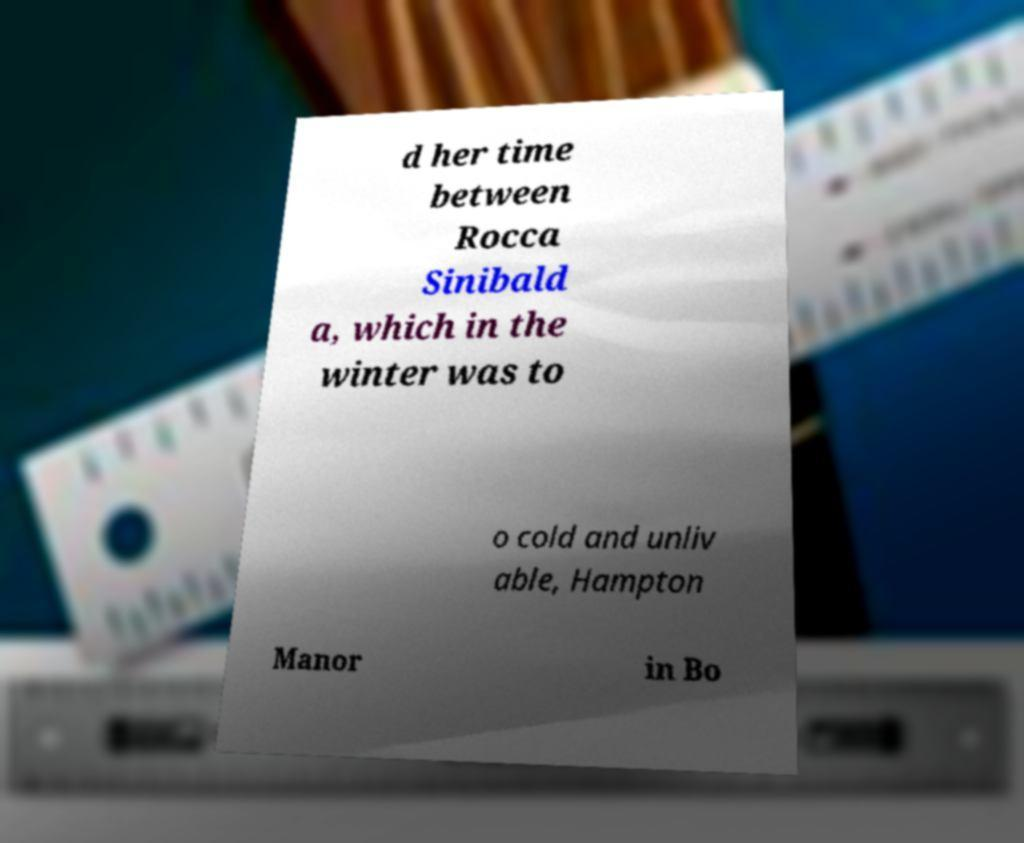Could you assist in decoding the text presented in this image and type it out clearly? d her time between Rocca Sinibald a, which in the winter was to o cold and unliv able, Hampton Manor in Bo 